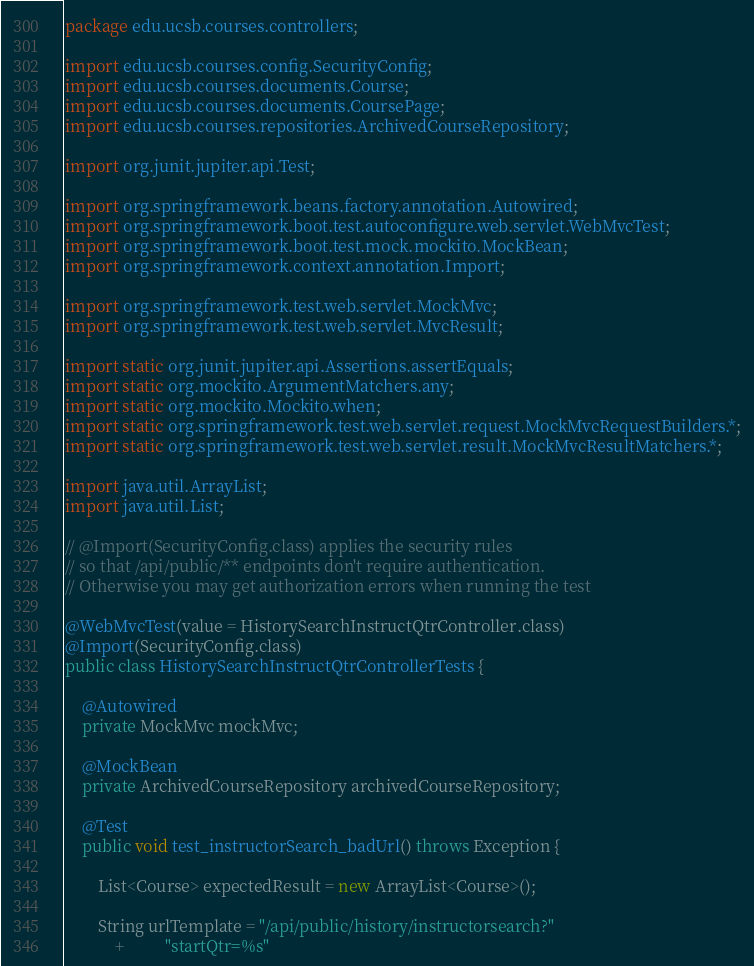Convert code to text. <code><loc_0><loc_0><loc_500><loc_500><_Java_>package edu.ucsb.courses.controllers;

import edu.ucsb.courses.config.SecurityConfig;
import edu.ucsb.courses.documents.Course;
import edu.ucsb.courses.documents.CoursePage;
import edu.ucsb.courses.repositories.ArchivedCourseRepository;

import org.junit.jupiter.api.Test;

import org.springframework.beans.factory.annotation.Autowired;
import org.springframework.boot.test.autoconfigure.web.servlet.WebMvcTest;
import org.springframework.boot.test.mock.mockito.MockBean;
import org.springframework.context.annotation.Import;

import org.springframework.test.web.servlet.MockMvc;
import org.springframework.test.web.servlet.MvcResult;

import static org.junit.jupiter.api.Assertions.assertEquals;
import static org.mockito.ArgumentMatchers.any;
import static org.mockito.Mockito.when;
import static org.springframework.test.web.servlet.request.MockMvcRequestBuilders.*;
import static org.springframework.test.web.servlet.result.MockMvcResultMatchers.*;

import java.util.ArrayList;
import java.util.List;

// @Import(SecurityConfig.class) applies the security rules 
// so that /api/public/** endpoints don't require authentication.
// Otherwise you may get authorization errors when running the test

@WebMvcTest(value = HistorySearchInstructQtrController.class)
@Import(SecurityConfig.class)
public class HistorySearchInstructQtrControllerTests {

    @Autowired
    private MockMvc mockMvc;

    @MockBean
    private ArchivedCourseRepository archivedCourseRepository;

    @Test
    public void test_instructorSearch_badUrl() throws Exception {
        
        List<Course> expectedResult = new ArrayList<Course>();

        String urlTemplate = "/api/public/history/instructorsearch?"
            +          "startQtr=%s"</code> 